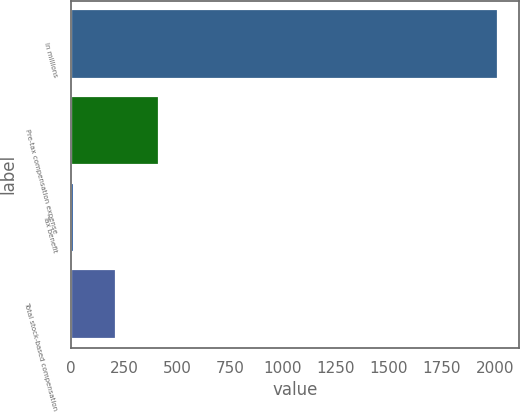<chart> <loc_0><loc_0><loc_500><loc_500><bar_chart><fcel>In millions<fcel>Pre-tax compensation expense<fcel>Tax benefit<fcel>Total stock-based compensation<nl><fcel>2015<fcel>412.6<fcel>12<fcel>212.3<nl></chart> 